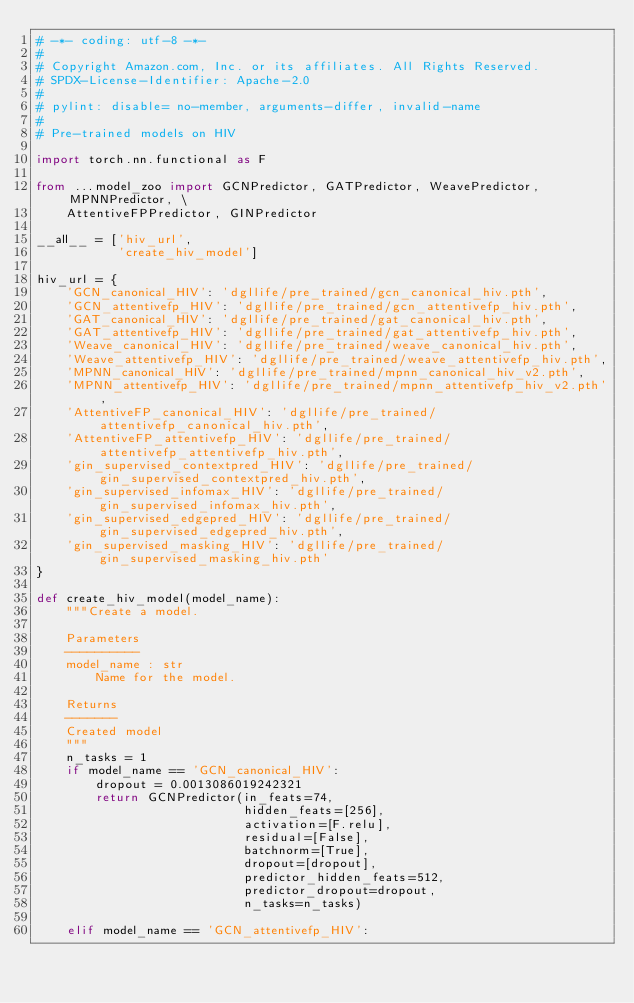Convert code to text. <code><loc_0><loc_0><loc_500><loc_500><_Python_># -*- coding: utf-8 -*-
#
# Copyright Amazon.com, Inc. or its affiliates. All Rights Reserved.
# SPDX-License-Identifier: Apache-2.0
#
# pylint: disable= no-member, arguments-differ, invalid-name
#
# Pre-trained models on HIV

import torch.nn.functional as F

from ...model_zoo import GCNPredictor, GATPredictor, WeavePredictor, MPNNPredictor, \
    AttentiveFPPredictor, GINPredictor

__all__ = ['hiv_url',
           'create_hiv_model']

hiv_url = {
    'GCN_canonical_HIV': 'dgllife/pre_trained/gcn_canonical_hiv.pth',
    'GCN_attentivefp_HIV': 'dgllife/pre_trained/gcn_attentivefp_hiv.pth',
    'GAT_canonical_HIV': 'dgllife/pre_trained/gat_canonical_hiv.pth',
    'GAT_attentivefp_HIV': 'dgllife/pre_trained/gat_attentivefp_hiv.pth',
    'Weave_canonical_HIV': 'dgllife/pre_trained/weave_canonical_hiv.pth',
    'Weave_attentivefp_HIV': 'dgllife/pre_trained/weave_attentivefp_hiv.pth',
    'MPNN_canonical_HIV': 'dgllife/pre_trained/mpnn_canonical_hiv_v2.pth',
    'MPNN_attentivefp_HIV': 'dgllife/pre_trained/mpnn_attentivefp_hiv_v2.pth',
    'AttentiveFP_canonical_HIV': 'dgllife/pre_trained/attentivefp_canonical_hiv.pth',
    'AttentiveFP_attentivefp_HIV': 'dgllife/pre_trained/attentivefp_attentivefp_hiv.pth',
    'gin_supervised_contextpred_HIV': 'dgllife/pre_trained/gin_supervised_contextpred_hiv.pth',
    'gin_supervised_infomax_HIV': 'dgllife/pre_trained/gin_supervised_infomax_hiv.pth',
    'gin_supervised_edgepred_HIV': 'dgllife/pre_trained/gin_supervised_edgepred_hiv.pth',
    'gin_supervised_masking_HIV': 'dgllife/pre_trained/gin_supervised_masking_hiv.pth'
}

def create_hiv_model(model_name):
    """Create a model.

    Parameters
    ----------
    model_name : str
        Name for the model.

    Returns
    -------
    Created model
    """
    n_tasks = 1
    if model_name == 'GCN_canonical_HIV':
        dropout = 0.0013086019242321
        return GCNPredictor(in_feats=74,
                            hidden_feats=[256],
                            activation=[F.relu],
                            residual=[False],
                            batchnorm=[True],
                            dropout=[dropout],
                            predictor_hidden_feats=512,
                            predictor_dropout=dropout,
                            n_tasks=n_tasks)

    elif model_name == 'GCN_attentivefp_HIV':</code> 